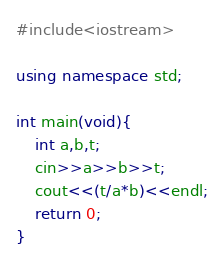Convert code to text. <code><loc_0><loc_0><loc_500><loc_500><_C++_>#include<iostream>

using namespace std;

int main(void){
    int a,b,t;
    cin>>a>>b>>t;
    cout<<(t/a*b)<<endl;
    return 0;
}</code> 